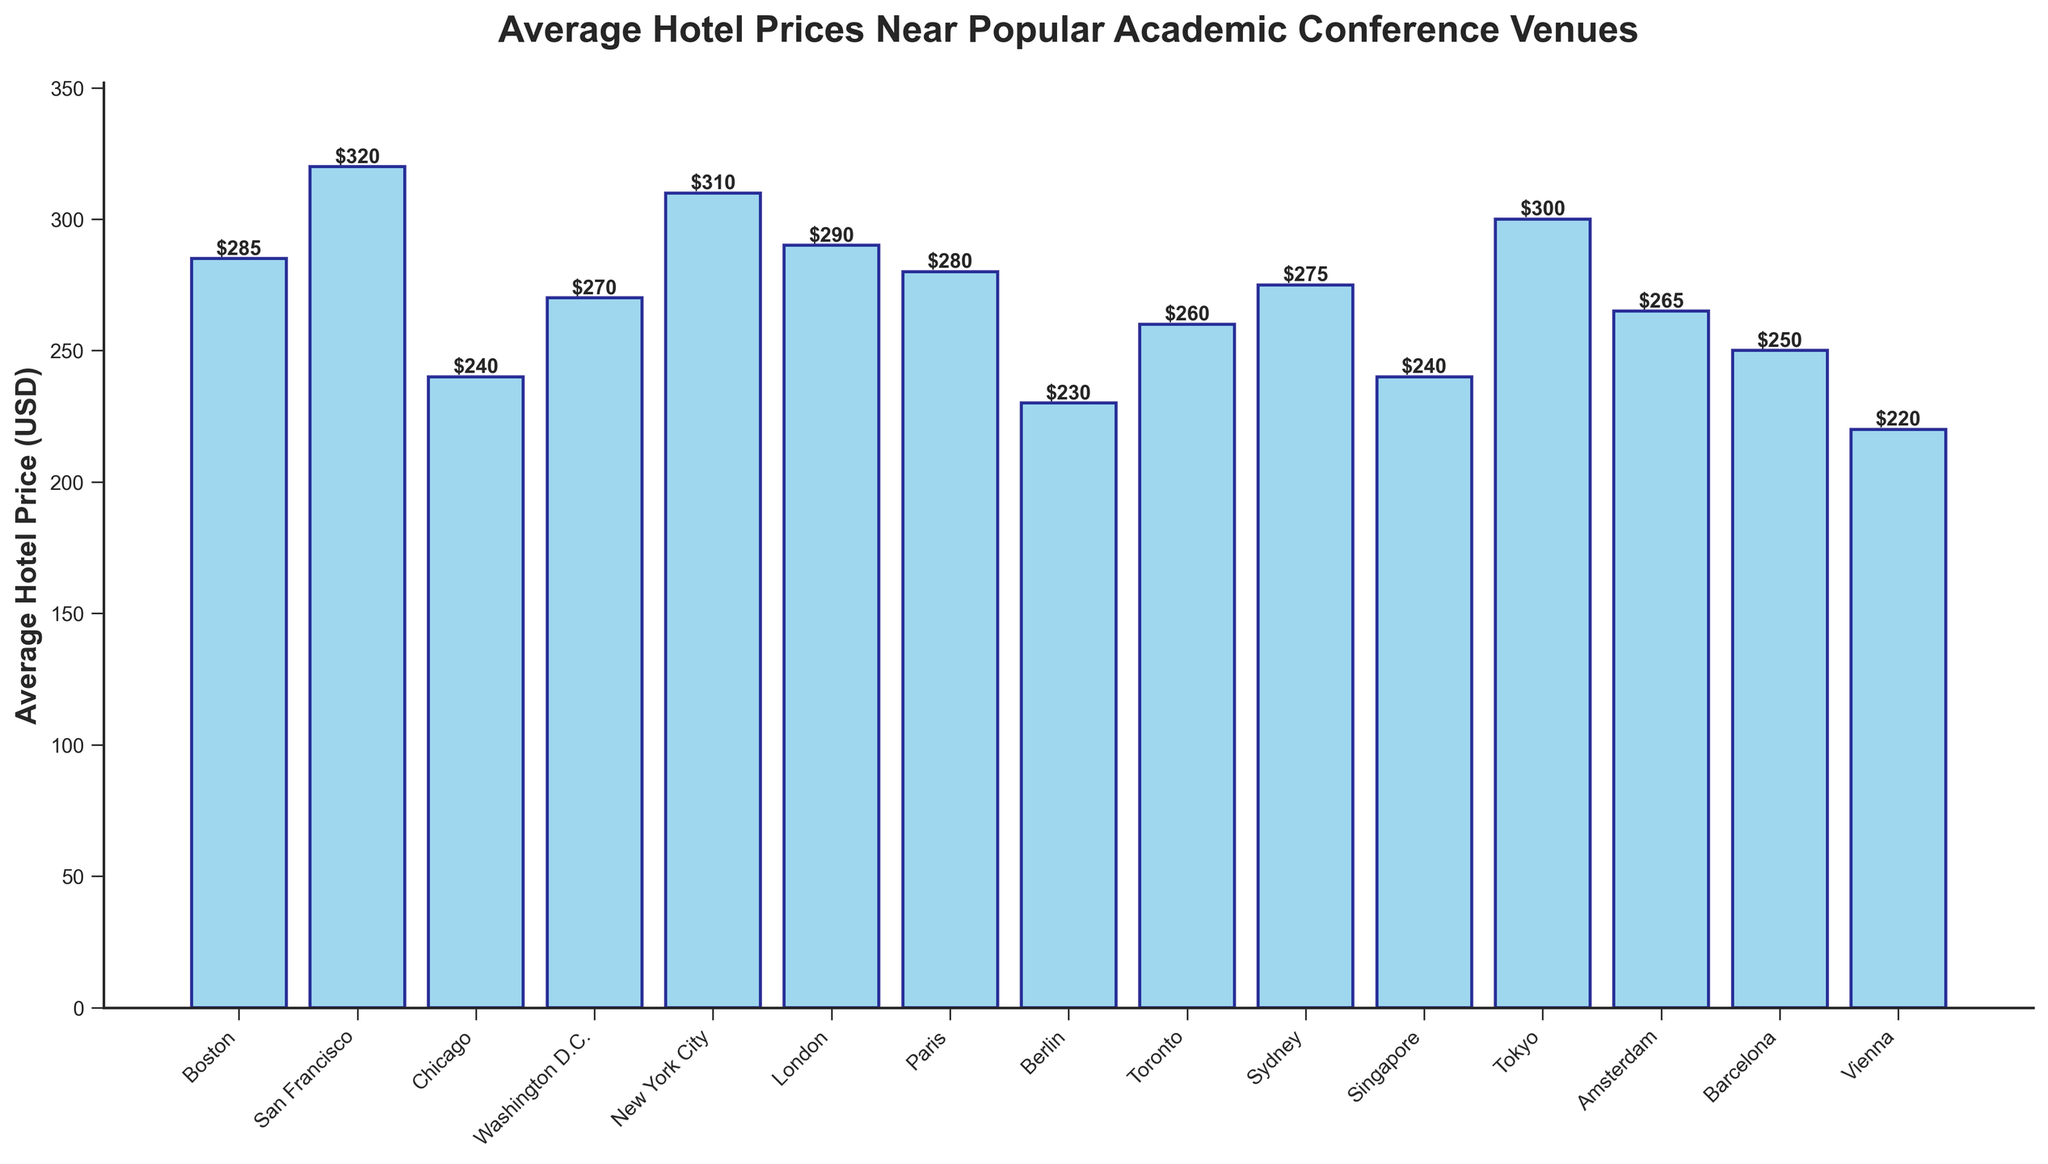What city has the highest average hotel price near its conference venue? To determine this, we need to identify the city with the tallest bar in the chart. The tallest bar represents San Francisco, with an average hotel price of $320.
Answer: San Francisco Which conference venue has the lowest average hotel price, and what is the price? Locate the shortest bar in the chart. The shortest bar represents Vienna, with an average hotel price of $220.
Answer: Vienna, $220 What is the difference in average hotel prices between New York City and Chicago? The average hotel price for New York City is $310, and for Chicago, it is $240. Subtract the smaller price from the larger one: $310 - $240 = $70.
Answer: $70 Which cities have average hotel prices above $300? Find the cities whose bars reach above the $300 mark. These cities are San Francisco ($320) and Tokyo ($300), along with New York City ($310).
Answer: San Francisco, New York City, Tokyo What is the average hotel price across all the listed conference venues? Sum all the hotel prices and divide by the number of cities. The total sum is $285 + $320 + $240 + $270 + $310 + $290 + $280 + $230 + $260 + $275 + $240 + $300 + $265 + $250 + $220 = $4,335. There are 15 cities, so $4,335 / 15 = $289.
Answer: $289 Compare the average hotel prices between European cities and non-European cities. Which group has a higher average price? Separate European cities (London, Paris, Berlin, Amsterdam, Barcelona, Vienna) from non-European ones and calculate the average price for each group. European cities: (290 + 280 + 230 + 265 + 250 + 220) / 6 = $256. Non-European cities: (285 + 320 + 240 + 270 + 310 + 275 + 240 + 300) / 8 = $280. The average price is higher in non-European cities.
Answer: Non-European cities Which city in Asia has the lowest average hotel price, and what is the price? Look for the cities in Asia and find the one with the lowest price by comparing the bars. Singapore has the lowest average hotel price in Asia at $240.
Answer: Singapore, $240 How many cities have average hotel prices between $250 and $300? Count the bars in the chart that fall between the $250 and $300 range. The cities are Chicago ($240), Washington D.C. ($270), Toronto ($260), Sydney ($275), Amsterdam ($265), Barcelona ($250), Paris ($280), London ($290), Boston ($285). There are 9 cities in total.
Answer: 9 What is the combined average hotel price of cities in North America? Add the prices of Boston, San Francisco, Chicago, Washington D.C., New York City, and Toronto, then divide by the number of cities. The sum is $285 + $320 + $240 + $270 + $310 + $260 = $1,685. There are 6 cities, so $1,685 / 6 ≈ $281.
Answer: $281 